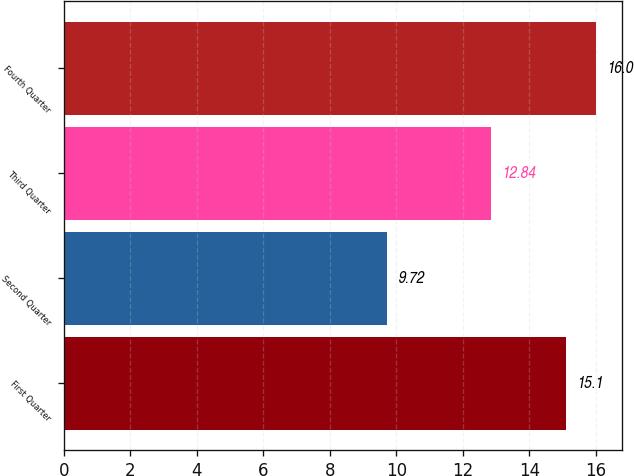Convert chart to OTSL. <chart><loc_0><loc_0><loc_500><loc_500><bar_chart><fcel>First Quarter<fcel>Second Quarter<fcel>Third Quarter<fcel>Fourth Quarter<nl><fcel>15.1<fcel>9.72<fcel>12.84<fcel>16<nl></chart> 